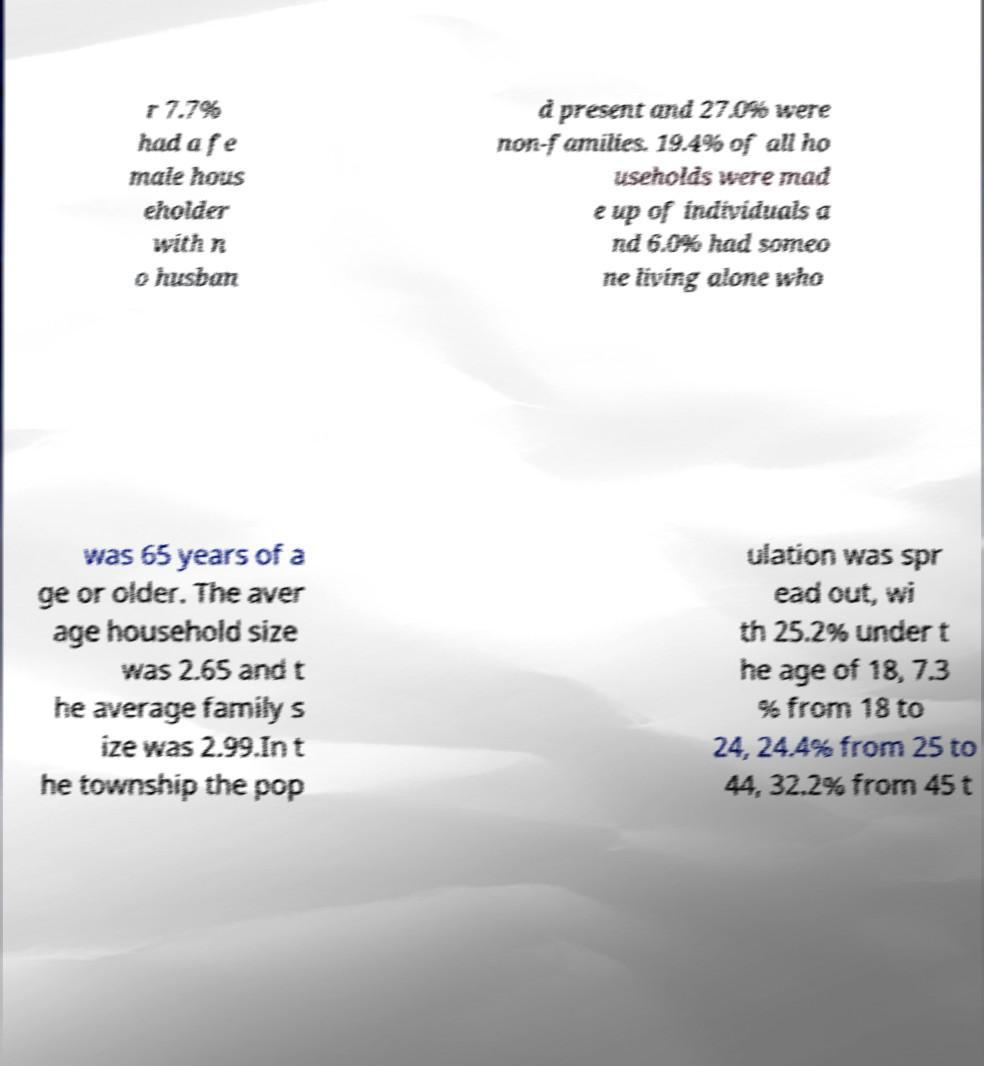What messages or text are displayed in this image? I need them in a readable, typed format. r 7.7% had a fe male hous eholder with n o husban d present and 27.0% were non-families. 19.4% of all ho useholds were mad e up of individuals a nd 6.0% had someo ne living alone who was 65 years of a ge or older. The aver age household size was 2.65 and t he average family s ize was 2.99.In t he township the pop ulation was spr ead out, wi th 25.2% under t he age of 18, 7.3 % from 18 to 24, 24.4% from 25 to 44, 32.2% from 45 t 